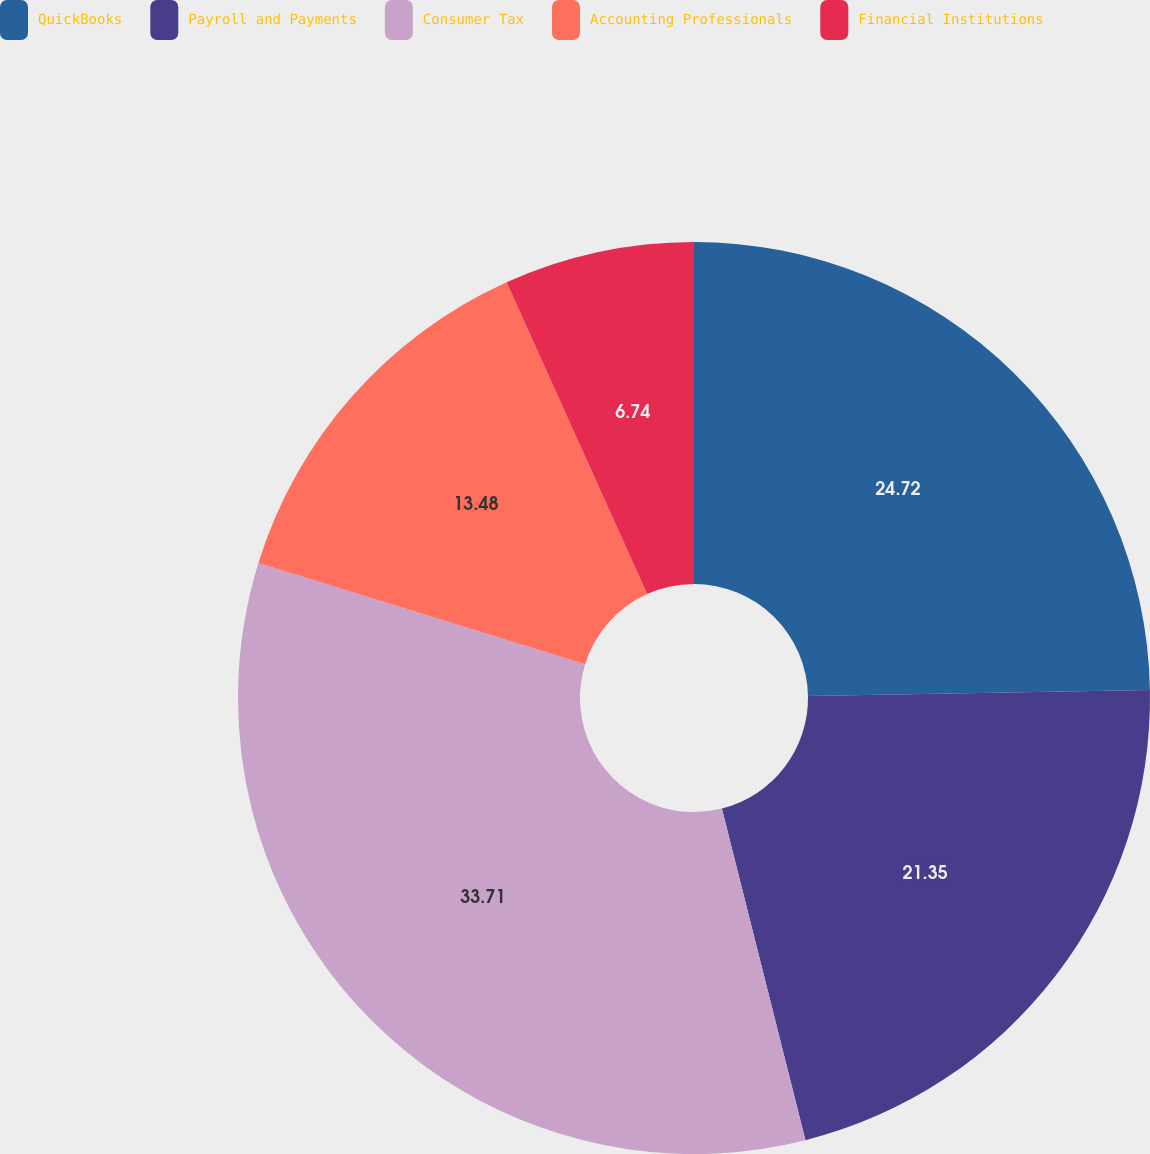Convert chart. <chart><loc_0><loc_0><loc_500><loc_500><pie_chart><fcel>QuickBooks<fcel>Payroll and Payments<fcel>Consumer Tax<fcel>Accounting Professionals<fcel>Financial Institutions<nl><fcel>24.72%<fcel>21.35%<fcel>33.71%<fcel>13.48%<fcel>6.74%<nl></chart> 